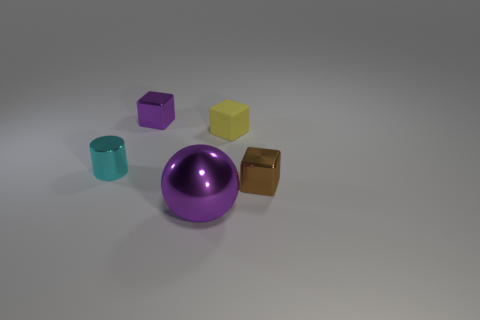What is the tiny purple block made of? The tiny purple block appears to have a smooth surface and a reflective quality, indicating it could be made of a polished material such as plastic or a coated metal, commonly used in manufacturing toys or decorative items. 